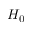Convert formula to latex. <formula><loc_0><loc_0><loc_500><loc_500>H _ { 0 }</formula> 